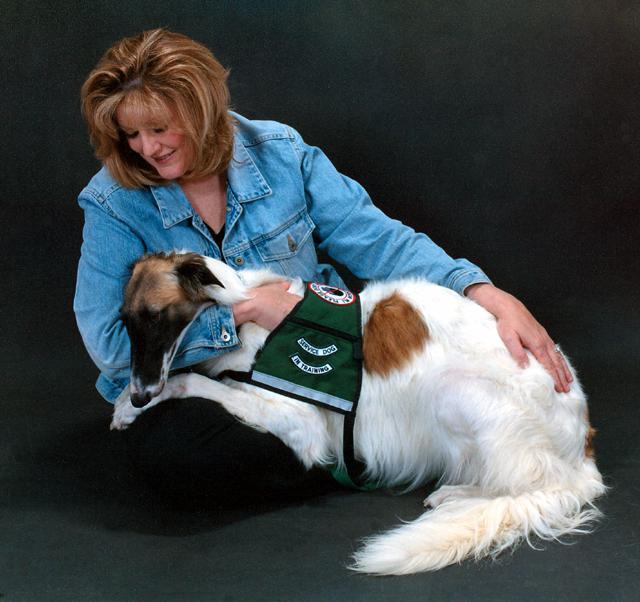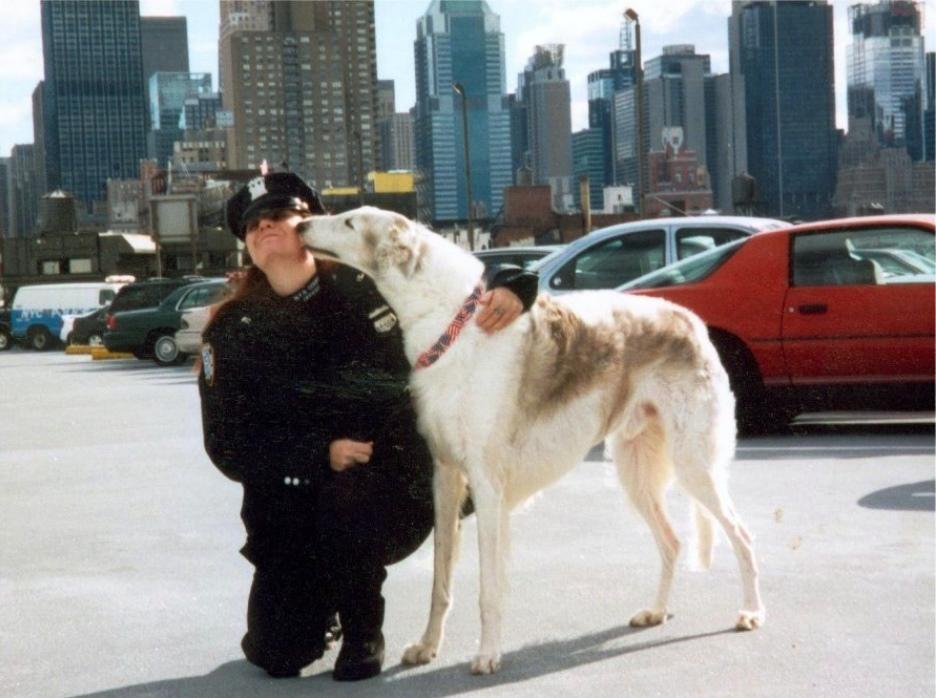The first image is the image on the left, the second image is the image on the right. Considering the images on both sides, is "There is 1 dog facing left in both images." valid? Answer yes or no. Yes. The first image is the image on the left, the second image is the image on the right. Examine the images to the left and right. Is the description "There is a woman in a denim shirt touching a dog in one of the images." accurate? Answer yes or no. Yes. 